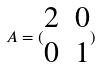Convert formula to latex. <formula><loc_0><loc_0><loc_500><loc_500>A = ( \begin{matrix} 2 & 0 \\ 0 & 1 \end{matrix} )</formula> 